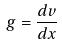Convert formula to latex. <formula><loc_0><loc_0><loc_500><loc_500>g = \frac { d v } { d x }</formula> 